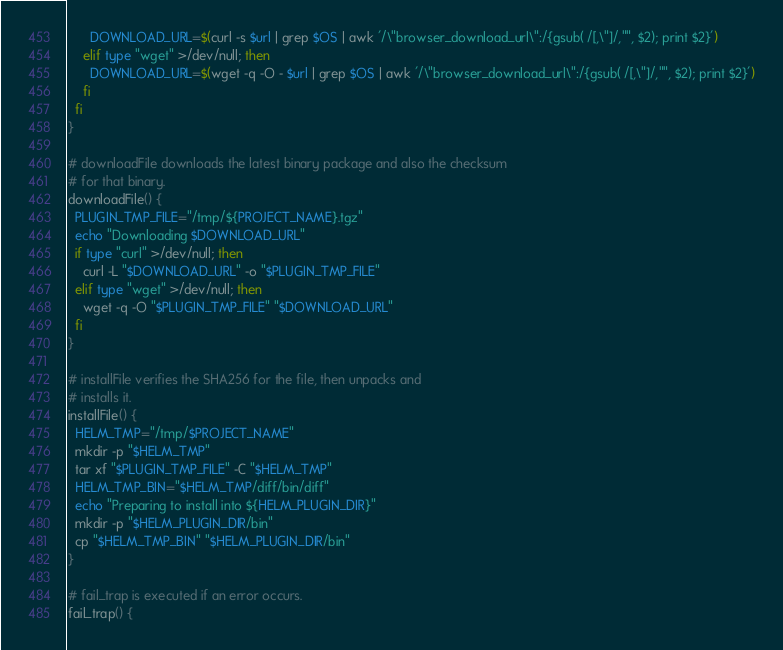<code> <loc_0><loc_0><loc_500><loc_500><_Bash_>      DOWNLOAD_URL=$(curl -s $url | grep $OS | awk '/\"browser_download_url\":/{gsub( /[,\"]/,"", $2); print $2}')
    elif type "wget" >/dev/null; then
      DOWNLOAD_URL=$(wget -q -O - $url | grep $OS | awk '/\"browser_download_url\":/{gsub( /[,\"]/,"", $2); print $2}')
    fi
  fi
}

# downloadFile downloads the latest binary package and also the checksum
# for that binary.
downloadFile() {
  PLUGIN_TMP_FILE="/tmp/${PROJECT_NAME}.tgz"
  echo "Downloading $DOWNLOAD_URL"
  if type "curl" >/dev/null; then
    curl -L "$DOWNLOAD_URL" -o "$PLUGIN_TMP_FILE"
  elif type "wget" >/dev/null; then
    wget -q -O "$PLUGIN_TMP_FILE" "$DOWNLOAD_URL"
  fi
}

# installFile verifies the SHA256 for the file, then unpacks and
# installs it.
installFile() {
  HELM_TMP="/tmp/$PROJECT_NAME"
  mkdir -p "$HELM_TMP"
  tar xf "$PLUGIN_TMP_FILE" -C "$HELM_TMP"
  HELM_TMP_BIN="$HELM_TMP/diff/bin/diff"
  echo "Preparing to install into ${HELM_PLUGIN_DIR}"
  mkdir -p "$HELM_PLUGIN_DIR/bin"
  cp "$HELM_TMP_BIN" "$HELM_PLUGIN_DIR/bin"
}

# fail_trap is executed if an error occurs.
fail_trap() {</code> 